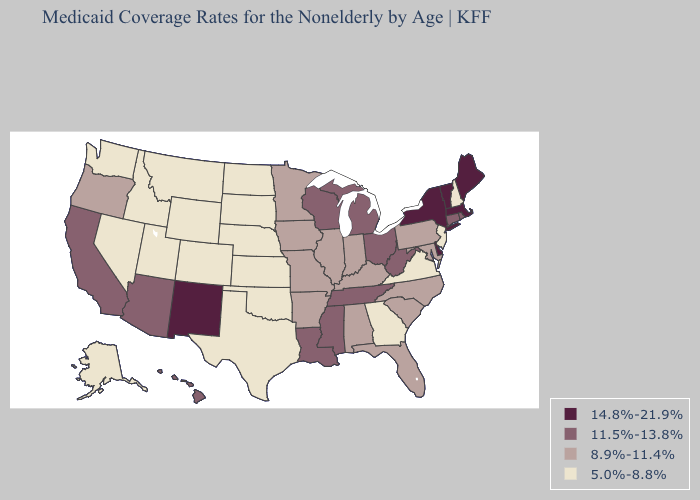What is the value of South Dakota?
Answer briefly. 5.0%-8.8%. Name the states that have a value in the range 11.5%-13.8%?
Short answer required. Arizona, California, Connecticut, Hawaii, Louisiana, Michigan, Mississippi, Ohio, Rhode Island, Tennessee, West Virginia, Wisconsin. Name the states that have a value in the range 8.9%-11.4%?
Keep it brief. Alabama, Arkansas, Florida, Illinois, Indiana, Iowa, Kentucky, Maryland, Minnesota, Missouri, North Carolina, Oregon, Pennsylvania, South Carolina. Among the states that border Arizona , does California have the highest value?
Keep it brief. No. Name the states that have a value in the range 5.0%-8.8%?
Short answer required. Alaska, Colorado, Georgia, Idaho, Kansas, Montana, Nebraska, Nevada, New Hampshire, New Jersey, North Dakota, Oklahoma, South Dakota, Texas, Utah, Virginia, Washington, Wyoming. Name the states that have a value in the range 8.9%-11.4%?
Answer briefly. Alabama, Arkansas, Florida, Illinois, Indiana, Iowa, Kentucky, Maryland, Minnesota, Missouri, North Carolina, Oregon, Pennsylvania, South Carolina. What is the value of Missouri?
Short answer required. 8.9%-11.4%. Name the states that have a value in the range 8.9%-11.4%?
Short answer required. Alabama, Arkansas, Florida, Illinois, Indiana, Iowa, Kentucky, Maryland, Minnesota, Missouri, North Carolina, Oregon, Pennsylvania, South Carolina. Among the states that border Nevada , does Arizona have the lowest value?
Write a very short answer. No. Name the states that have a value in the range 11.5%-13.8%?
Write a very short answer. Arizona, California, Connecticut, Hawaii, Louisiana, Michigan, Mississippi, Ohio, Rhode Island, Tennessee, West Virginia, Wisconsin. Does Mississippi have the same value as Wyoming?
Quick response, please. No. Among the states that border Arizona , does New Mexico have the highest value?
Be succinct. Yes. Which states have the highest value in the USA?
Write a very short answer. Delaware, Maine, Massachusetts, New Mexico, New York, Vermont. What is the value of Louisiana?
Quick response, please. 11.5%-13.8%. Name the states that have a value in the range 8.9%-11.4%?
Write a very short answer. Alabama, Arkansas, Florida, Illinois, Indiana, Iowa, Kentucky, Maryland, Minnesota, Missouri, North Carolina, Oregon, Pennsylvania, South Carolina. 